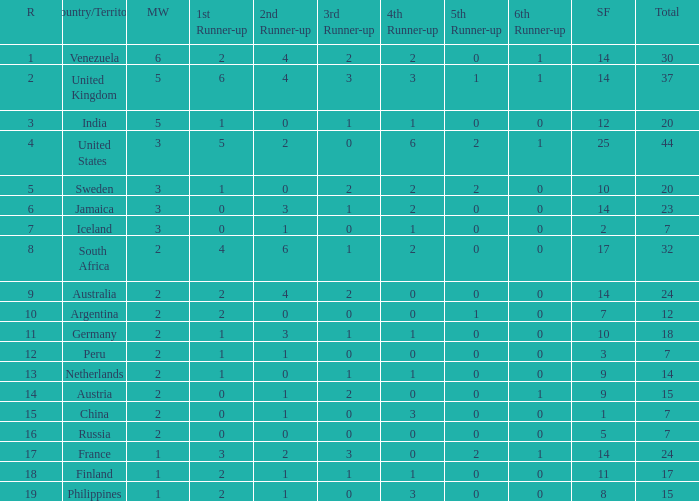What is Venezuela's total rank? 30.0. 